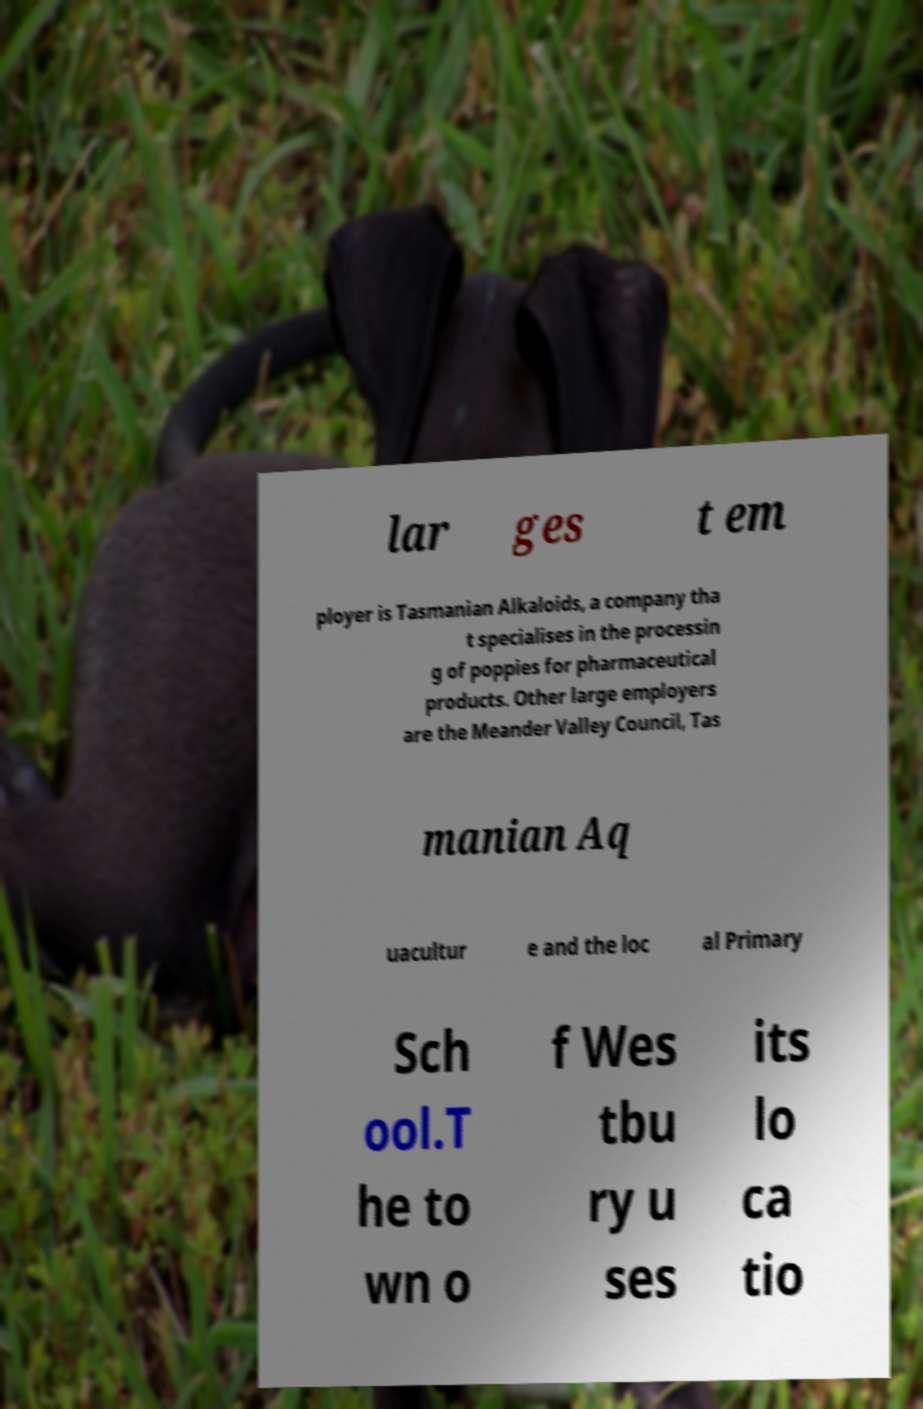What messages or text are displayed in this image? I need them in a readable, typed format. lar ges t em ployer is Tasmanian Alkaloids, a company tha t specialises in the processin g of poppies for pharmaceutical products. Other large employers are the Meander Valley Council, Tas manian Aq uacultur e and the loc al Primary Sch ool.T he to wn o f Wes tbu ry u ses its lo ca tio 